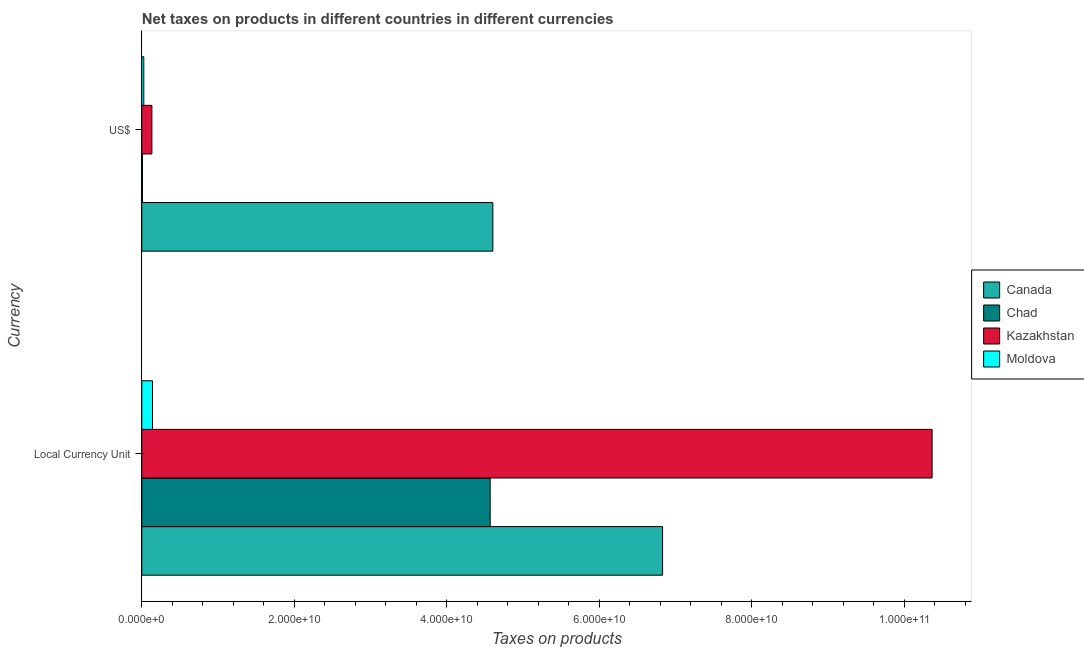How many different coloured bars are there?
Your response must be concise. 4. How many groups of bars are there?
Provide a succinct answer. 2. What is the label of the 1st group of bars from the top?
Offer a very short reply. US$. What is the net taxes in constant 2005 us$ in Canada?
Give a very brief answer. 6.83e+1. Across all countries, what is the maximum net taxes in constant 2005 us$?
Offer a terse response. 1.04e+11. Across all countries, what is the minimum net taxes in us$?
Your response must be concise. 7.75e+07. In which country was the net taxes in constant 2005 us$ maximum?
Ensure brevity in your answer.  Kazakhstan. In which country was the net taxes in us$ minimum?
Keep it short and to the point. Chad. What is the total net taxes in us$ in the graph?
Provide a succinct answer. 4.77e+1. What is the difference between the net taxes in constant 2005 us$ in Kazakhstan and that in Canada?
Your response must be concise. 3.54e+1. What is the difference between the net taxes in us$ in Kazakhstan and the net taxes in constant 2005 us$ in Chad?
Provide a short and direct response. -4.44e+1. What is the average net taxes in constant 2005 us$ per country?
Offer a terse response. 5.48e+1. What is the difference between the net taxes in constant 2005 us$ and net taxes in us$ in Canada?
Keep it short and to the point. 2.23e+1. What is the ratio of the net taxes in us$ in Kazakhstan to that in Chad?
Your answer should be compact. 17.09. In how many countries, is the net taxes in constant 2005 us$ greater than the average net taxes in constant 2005 us$ taken over all countries?
Provide a short and direct response. 2. What does the 3rd bar from the top in Local Currency Unit represents?
Offer a very short reply. Chad. What does the 4th bar from the bottom in Local Currency Unit represents?
Keep it short and to the point. Moldova. Are all the bars in the graph horizontal?
Your response must be concise. Yes. How many countries are there in the graph?
Offer a very short reply. 4. What is the difference between two consecutive major ticks on the X-axis?
Offer a terse response. 2.00e+1. Does the graph contain grids?
Offer a terse response. No. Where does the legend appear in the graph?
Ensure brevity in your answer.  Center right. What is the title of the graph?
Provide a succinct answer. Net taxes on products in different countries in different currencies. What is the label or title of the X-axis?
Your answer should be compact. Taxes on products. What is the label or title of the Y-axis?
Provide a succinct answer. Currency. What is the Taxes on products of Canada in Local Currency Unit?
Make the answer very short. 6.83e+1. What is the Taxes on products of Chad in Local Currency Unit?
Provide a succinct answer. 4.57e+1. What is the Taxes on products in Kazakhstan in Local Currency Unit?
Offer a terse response. 1.04e+11. What is the Taxes on products of Moldova in Local Currency Unit?
Your response must be concise. 1.40e+09. What is the Taxes on products of Canada in US$?
Offer a very short reply. 4.60e+1. What is the Taxes on products in Chad in US$?
Provide a short and direct response. 7.75e+07. What is the Taxes on products in Kazakhstan in US$?
Your response must be concise. 1.32e+09. What is the Taxes on products of Moldova in US$?
Offer a very short reply. 2.61e+08. Across all Currency, what is the maximum Taxes on products of Canada?
Your response must be concise. 6.83e+1. Across all Currency, what is the maximum Taxes on products in Chad?
Give a very brief answer. 4.57e+1. Across all Currency, what is the maximum Taxes on products of Kazakhstan?
Provide a succinct answer. 1.04e+11. Across all Currency, what is the maximum Taxes on products of Moldova?
Give a very brief answer. 1.40e+09. Across all Currency, what is the minimum Taxes on products in Canada?
Your response must be concise. 4.60e+1. Across all Currency, what is the minimum Taxes on products of Chad?
Keep it short and to the point. 7.75e+07. Across all Currency, what is the minimum Taxes on products in Kazakhstan?
Your answer should be compact. 1.32e+09. Across all Currency, what is the minimum Taxes on products in Moldova?
Keep it short and to the point. 2.61e+08. What is the total Taxes on products of Canada in the graph?
Provide a succinct answer. 1.14e+11. What is the total Taxes on products of Chad in the graph?
Keep it short and to the point. 4.58e+1. What is the total Taxes on products of Kazakhstan in the graph?
Keep it short and to the point. 1.05e+11. What is the total Taxes on products of Moldova in the graph?
Offer a terse response. 1.66e+09. What is the difference between the Taxes on products of Canada in Local Currency Unit and that in US$?
Your answer should be compact. 2.23e+1. What is the difference between the Taxes on products of Chad in Local Currency Unit and that in US$?
Your answer should be compact. 4.56e+1. What is the difference between the Taxes on products of Kazakhstan in Local Currency Unit and that in US$?
Your response must be concise. 1.02e+11. What is the difference between the Taxes on products in Moldova in Local Currency Unit and that in US$?
Provide a succinct answer. 1.14e+09. What is the difference between the Taxes on products in Canada in Local Currency Unit and the Taxes on products in Chad in US$?
Offer a terse response. 6.82e+1. What is the difference between the Taxes on products in Canada in Local Currency Unit and the Taxes on products in Kazakhstan in US$?
Make the answer very short. 6.70e+1. What is the difference between the Taxes on products in Canada in Local Currency Unit and the Taxes on products in Moldova in US$?
Give a very brief answer. 6.81e+1. What is the difference between the Taxes on products of Chad in Local Currency Unit and the Taxes on products of Kazakhstan in US$?
Your answer should be compact. 4.44e+1. What is the difference between the Taxes on products in Chad in Local Currency Unit and the Taxes on products in Moldova in US$?
Provide a succinct answer. 4.54e+1. What is the difference between the Taxes on products in Kazakhstan in Local Currency Unit and the Taxes on products in Moldova in US$?
Keep it short and to the point. 1.03e+11. What is the average Taxes on products of Canada per Currency?
Your answer should be very brief. 5.72e+1. What is the average Taxes on products in Chad per Currency?
Keep it short and to the point. 2.29e+1. What is the average Taxes on products of Kazakhstan per Currency?
Your response must be concise. 5.25e+1. What is the average Taxes on products in Moldova per Currency?
Your answer should be compact. 8.32e+08. What is the difference between the Taxes on products of Canada and Taxes on products of Chad in Local Currency Unit?
Give a very brief answer. 2.26e+1. What is the difference between the Taxes on products of Canada and Taxes on products of Kazakhstan in Local Currency Unit?
Offer a very short reply. -3.54e+1. What is the difference between the Taxes on products in Canada and Taxes on products in Moldova in Local Currency Unit?
Provide a succinct answer. 6.69e+1. What is the difference between the Taxes on products of Chad and Taxes on products of Kazakhstan in Local Currency Unit?
Keep it short and to the point. -5.80e+1. What is the difference between the Taxes on products in Chad and Taxes on products in Moldova in Local Currency Unit?
Provide a short and direct response. 4.43e+1. What is the difference between the Taxes on products of Kazakhstan and Taxes on products of Moldova in Local Currency Unit?
Offer a terse response. 1.02e+11. What is the difference between the Taxes on products of Canada and Taxes on products of Chad in US$?
Give a very brief answer. 4.60e+1. What is the difference between the Taxes on products of Canada and Taxes on products of Kazakhstan in US$?
Ensure brevity in your answer.  4.47e+1. What is the difference between the Taxes on products of Canada and Taxes on products of Moldova in US$?
Ensure brevity in your answer.  4.58e+1. What is the difference between the Taxes on products in Chad and Taxes on products in Kazakhstan in US$?
Offer a very short reply. -1.25e+09. What is the difference between the Taxes on products in Chad and Taxes on products in Moldova in US$?
Provide a succinct answer. -1.84e+08. What is the difference between the Taxes on products in Kazakhstan and Taxes on products in Moldova in US$?
Keep it short and to the point. 1.06e+09. What is the ratio of the Taxes on products in Canada in Local Currency Unit to that in US$?
Make the answer very short. 1.48. What is the ratio of the Taxes on products in Chad in Local Currency Unit to that in US$?
Provide a succinct answer. 589.95. What is the ratio of the Taxes on products of Kazakhstan in Local Currency Unit to that in US$?
Ensure brevity in your answer.  78.3. What is the ratio of the Taxes on products of Moldova in Local Currency Unit to that in US$?
Make the answer very short. 5.37. What is the difference between the highest and the second highest Taxes on products of Canada?
Keep it short and to the point. 2.23e+1. What is the difference between the highest and the second highest Taxes on products of Chad?
Offer a very short reply. 4.56e+1. What is the difference between the highest and the second highest Taxes on products of Kazakhstan?
Your answer should be very brief. 1.02e+11. What is the difference between the highest and the second highest Taxes on products in Moldova?
Keep it short and to the point. 1.14e+09. What is the difference between the highest and the lowest Taxes on products of Canada?
Ensure brevity in your answer.  2.23e+1. What is the difference between the highest and the lowest Taxes on products of Chad?
Ensure brevity in your answer.  4.56e+1. What is the difference between the highest and the lowest Taxes on products in Kazakhstan?
Provide a succinct answer. 1.02e+11. What is the difference between the highest and the lowest Taxes on products of Moldova?
Provide a succinct answer. 1.14e+09. 